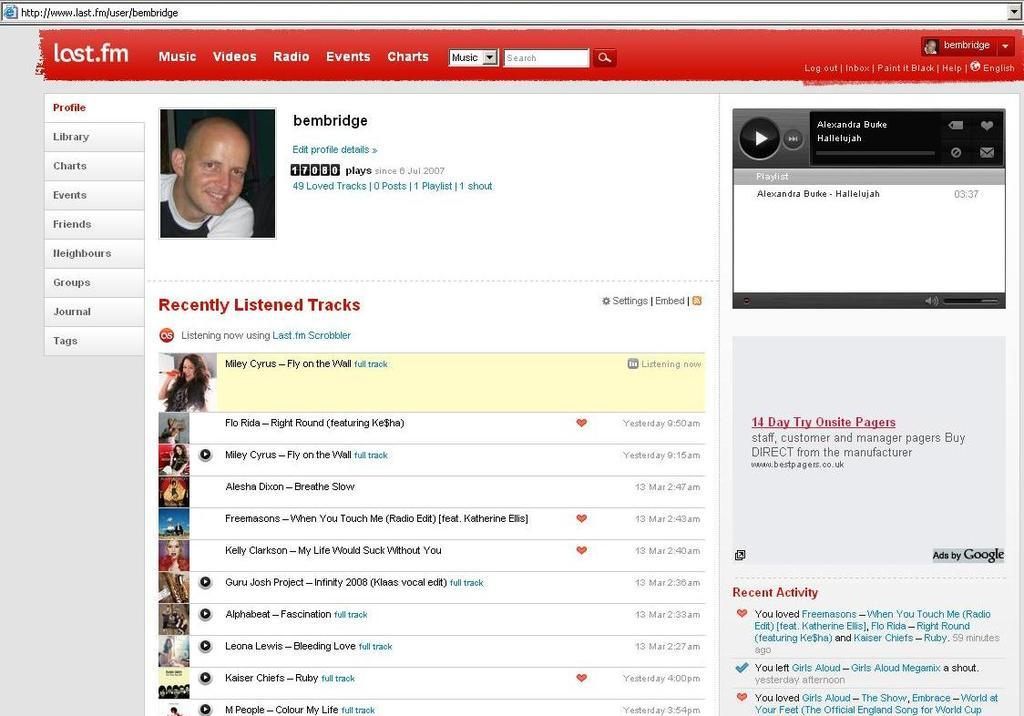What is the main subject of the image? The main subject of the image is a web page. What can be seen on the web page? There is a person's image and tags visible on the web page. What else is present in the image? There is a digital audio player on the right side of the image, and there is text visible in the image. What type of building can be seen on the roof in the image? There is no building or roof present in the image; it features a web page and related elements. 